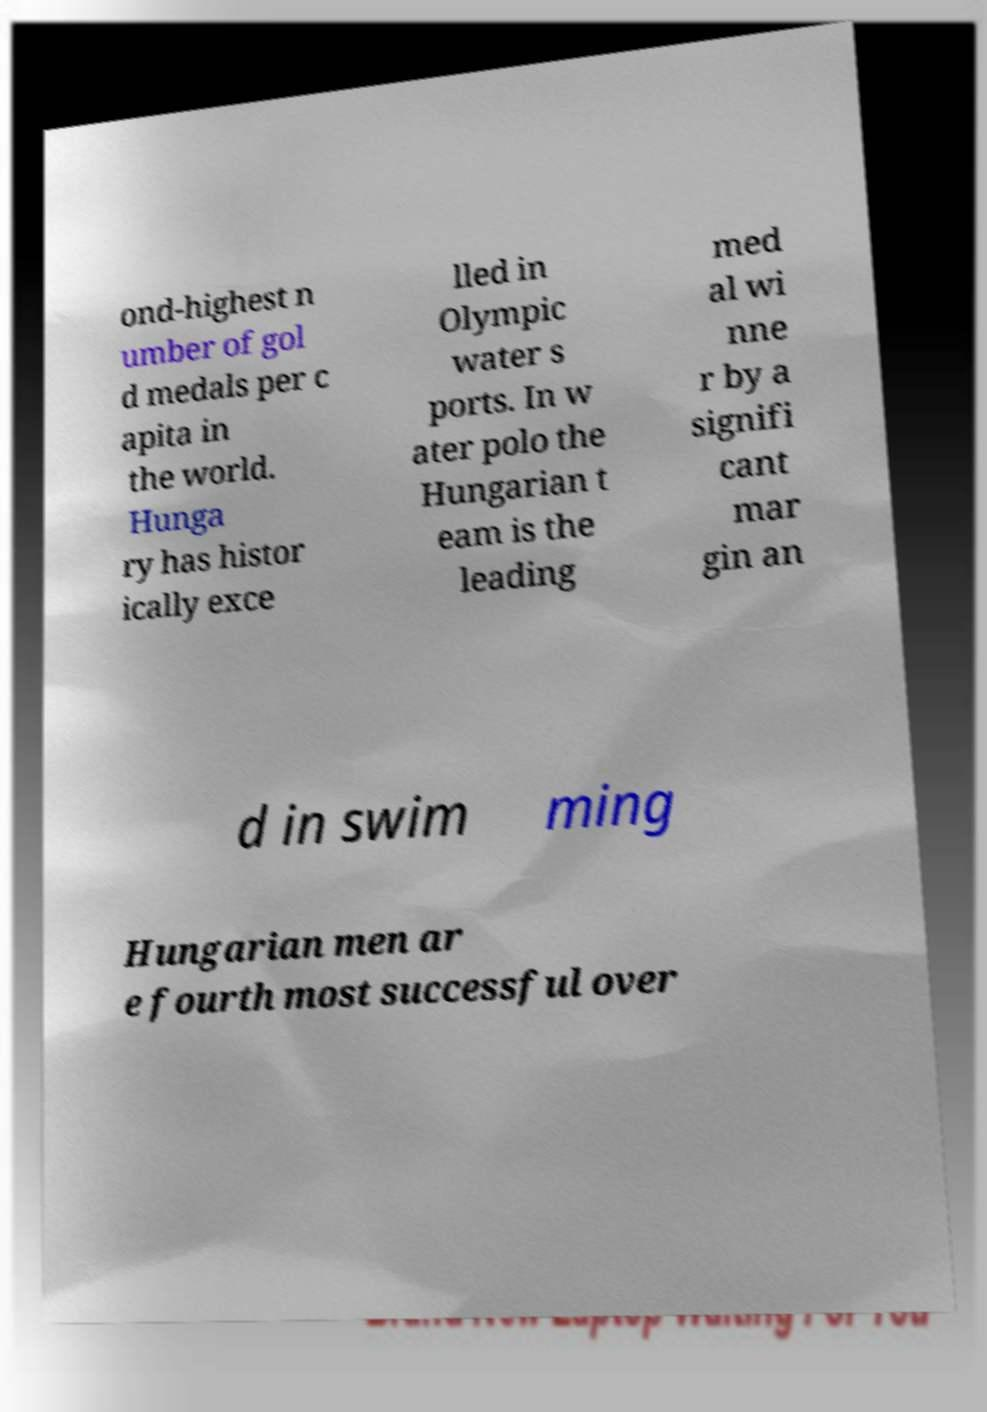Please read and relay the text visible in this image. What does it say? ond-highest n umber of gol d medals per c apita in the world. Hunga ry has histor ically exce lled in Olympic water s ports. In w ater polo the Hungarian t eam is the leading med al wi nne r by a signifi cant mar gin an d in swim ming Hungarian men ar e fourth most successful over 